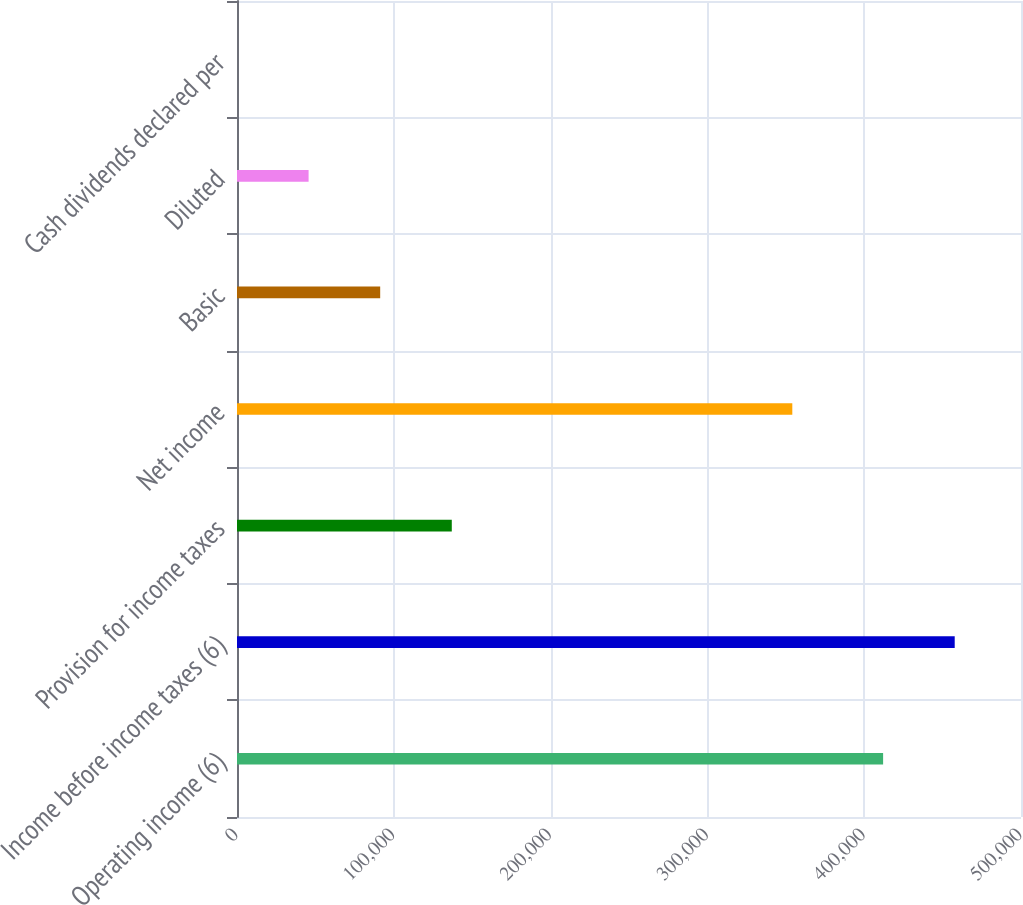Convert chart. <chart><loc_0><loc_0><loc_500><loc_500><bar_chart><fcel>Operating income (6)<fcel>Income before income taxes (6)<fcel>Provision for income taxes<fcel>Net income<fcel>Basic<fcel>Diluted<fcel>Cash dividends declared per<nl><fcel>412062<fcel>457722<fcel>136981<fcel>354149<fcel>91320.6<fcel>45660.4<fcel>0.28<nl></chart> 